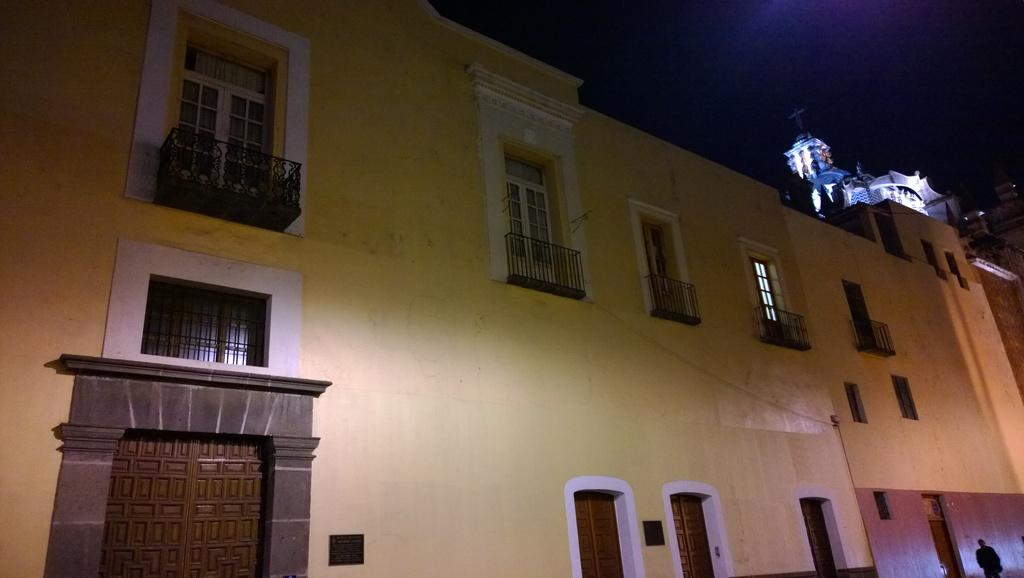What type of structures can be seen in the image? There are buildings in the image. What can be observed illuminating the scene in the image? There are lights in the image. What material is used for the rods visible in the image? There are metal rods in the image. Can you describe the person in the image? There is a person at the right bottom of the image. What type of leaf is being used as a plate for the person's lunch in the image? There is no leaf or lunch present in the image; it only features buildings, lights, metal rods, and a person. What type of meat is the person holding in the image? There is no meat present in the image; it only features buildings, lights, metal rods, and a person. 